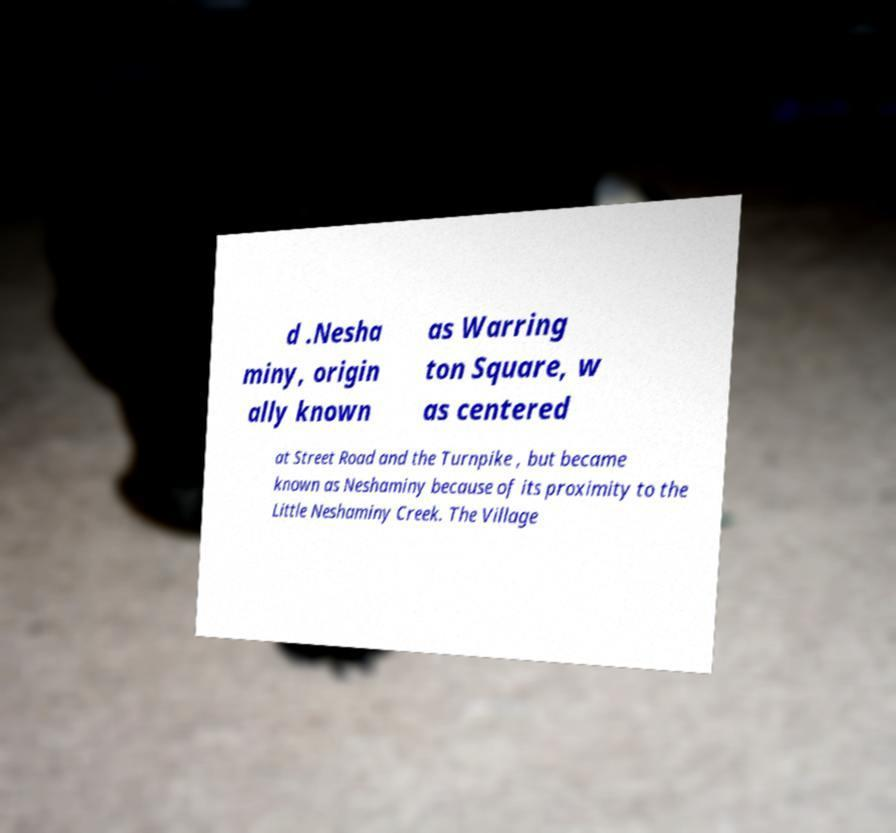Could you assist in decoding the text presented in this image and type it out clearly? d .Nesha miny, origin ally known as Warring ton Square, w as centered at Street Road and the Turnpike , but became known as Neshaminy because of its proximity to the Little Neshaminy Creek. The Village 